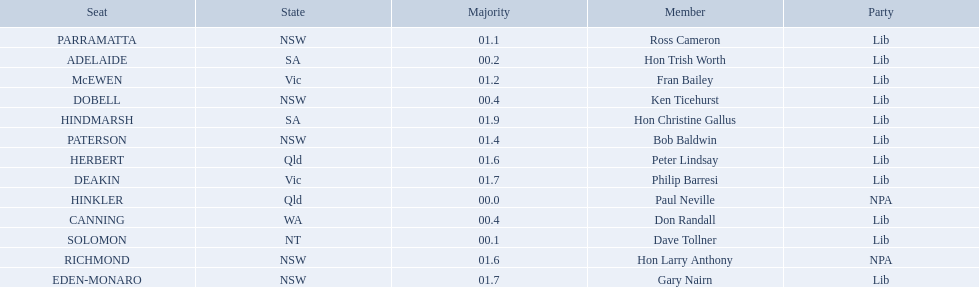What state does hinkler belong too? Qld. What is the majority of difference between sa and qld? 01.9. 